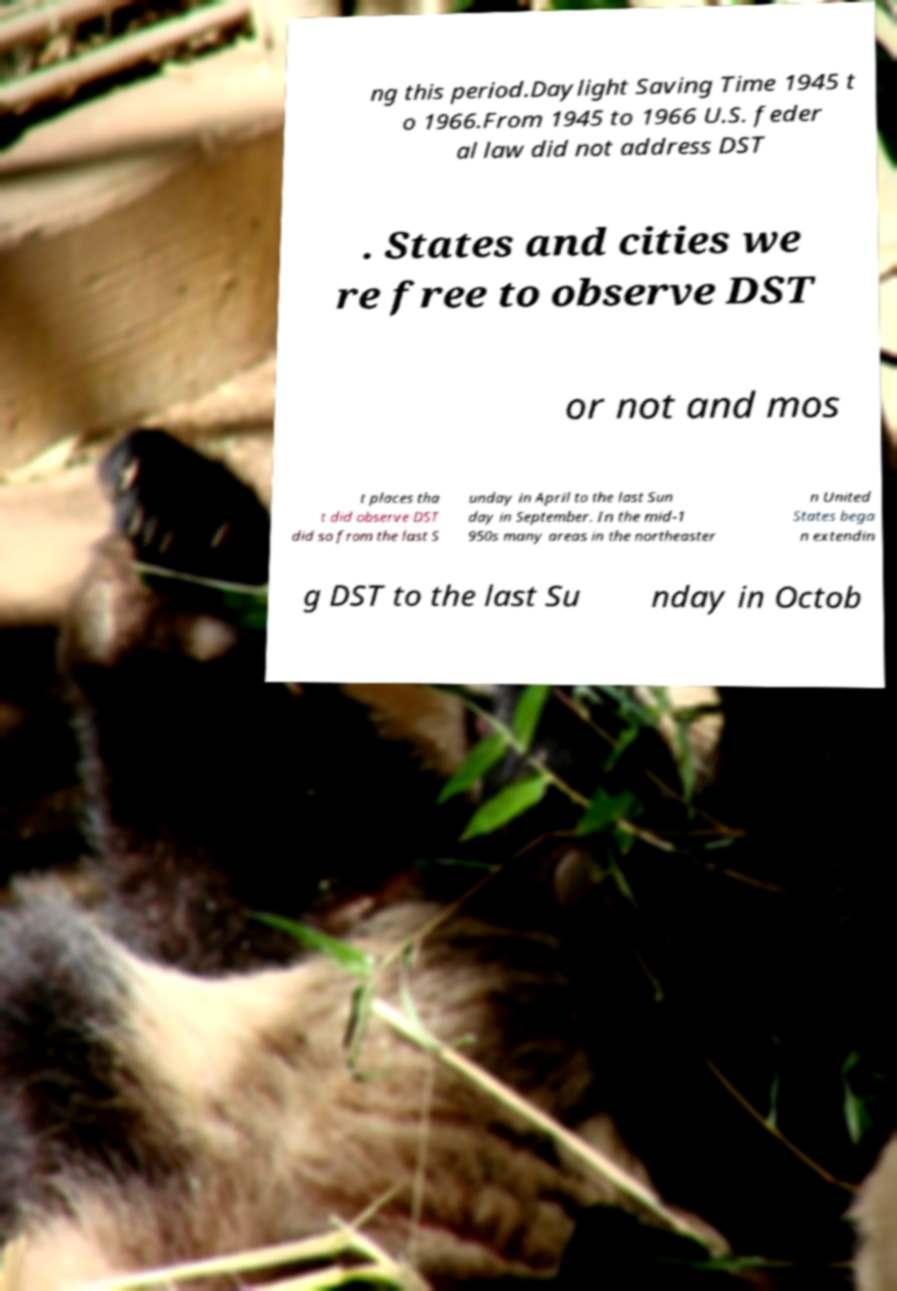Please read and relay the text visible in this image. What does it say? ng this period.Daylight Saving Time 1945 t o 1966.From 1945 to 1966 U.S. feder al law did not address DST . States and cities we re free to observe DST or not and mos t places tha t did observe DST did so from the last S unday in April to the last Sun day in September. In the mid-1 950s many areas in the northeaster n United States bega n extendin g DST to the last Su nday in Octob 